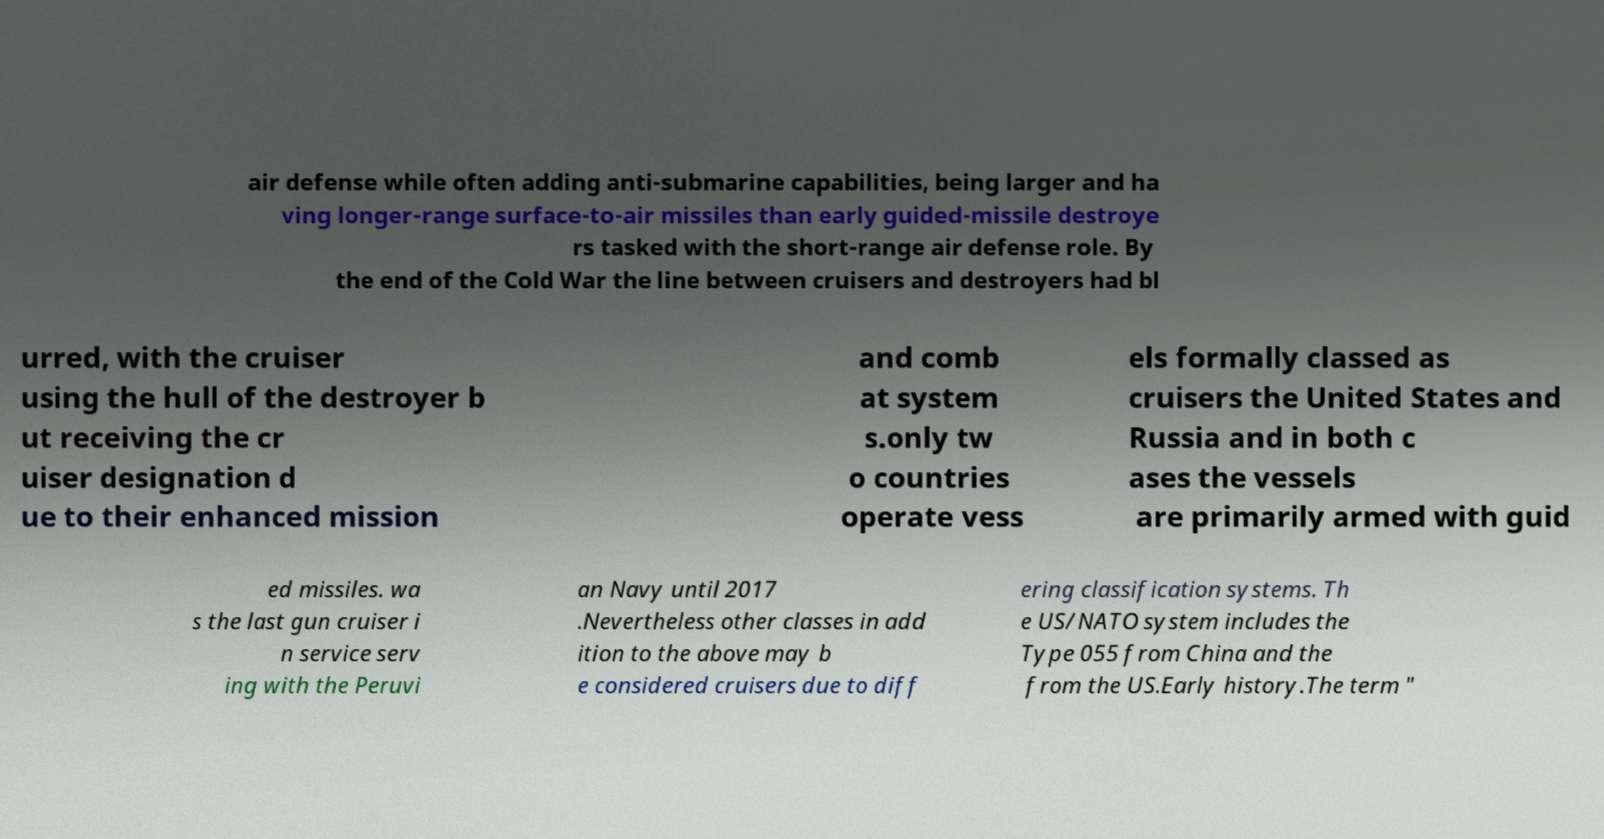Could you extract and type out the text from this image? air defense while often adding anti-submarine capabilities, being larger and ha ving longer-range surface-to-air missiles than early guided-missile destroye rs tasked with the short-range air defense role. By the end of the Cold War the line between cruisers and destroyers had bl urred, with the cruiser using the hull of the destroyer b ut receiving the cr uiser designation d ue to their enhanced mission and comb at system s.only tw o countries operate vess els formally classed as cruisers the United States and Russia and in both c ases the vessels are primarily armed with guid ed missiles. wa s the last gun cruiser i n service serv ing with the Peruvi an Navy until 2017 .Nevertheless other classes in add ition to the above may b e considered cruisers due to diff ering classification systems. Th e US/NATO system includes the Type 055 from China and the from the US.Early history.The term " 